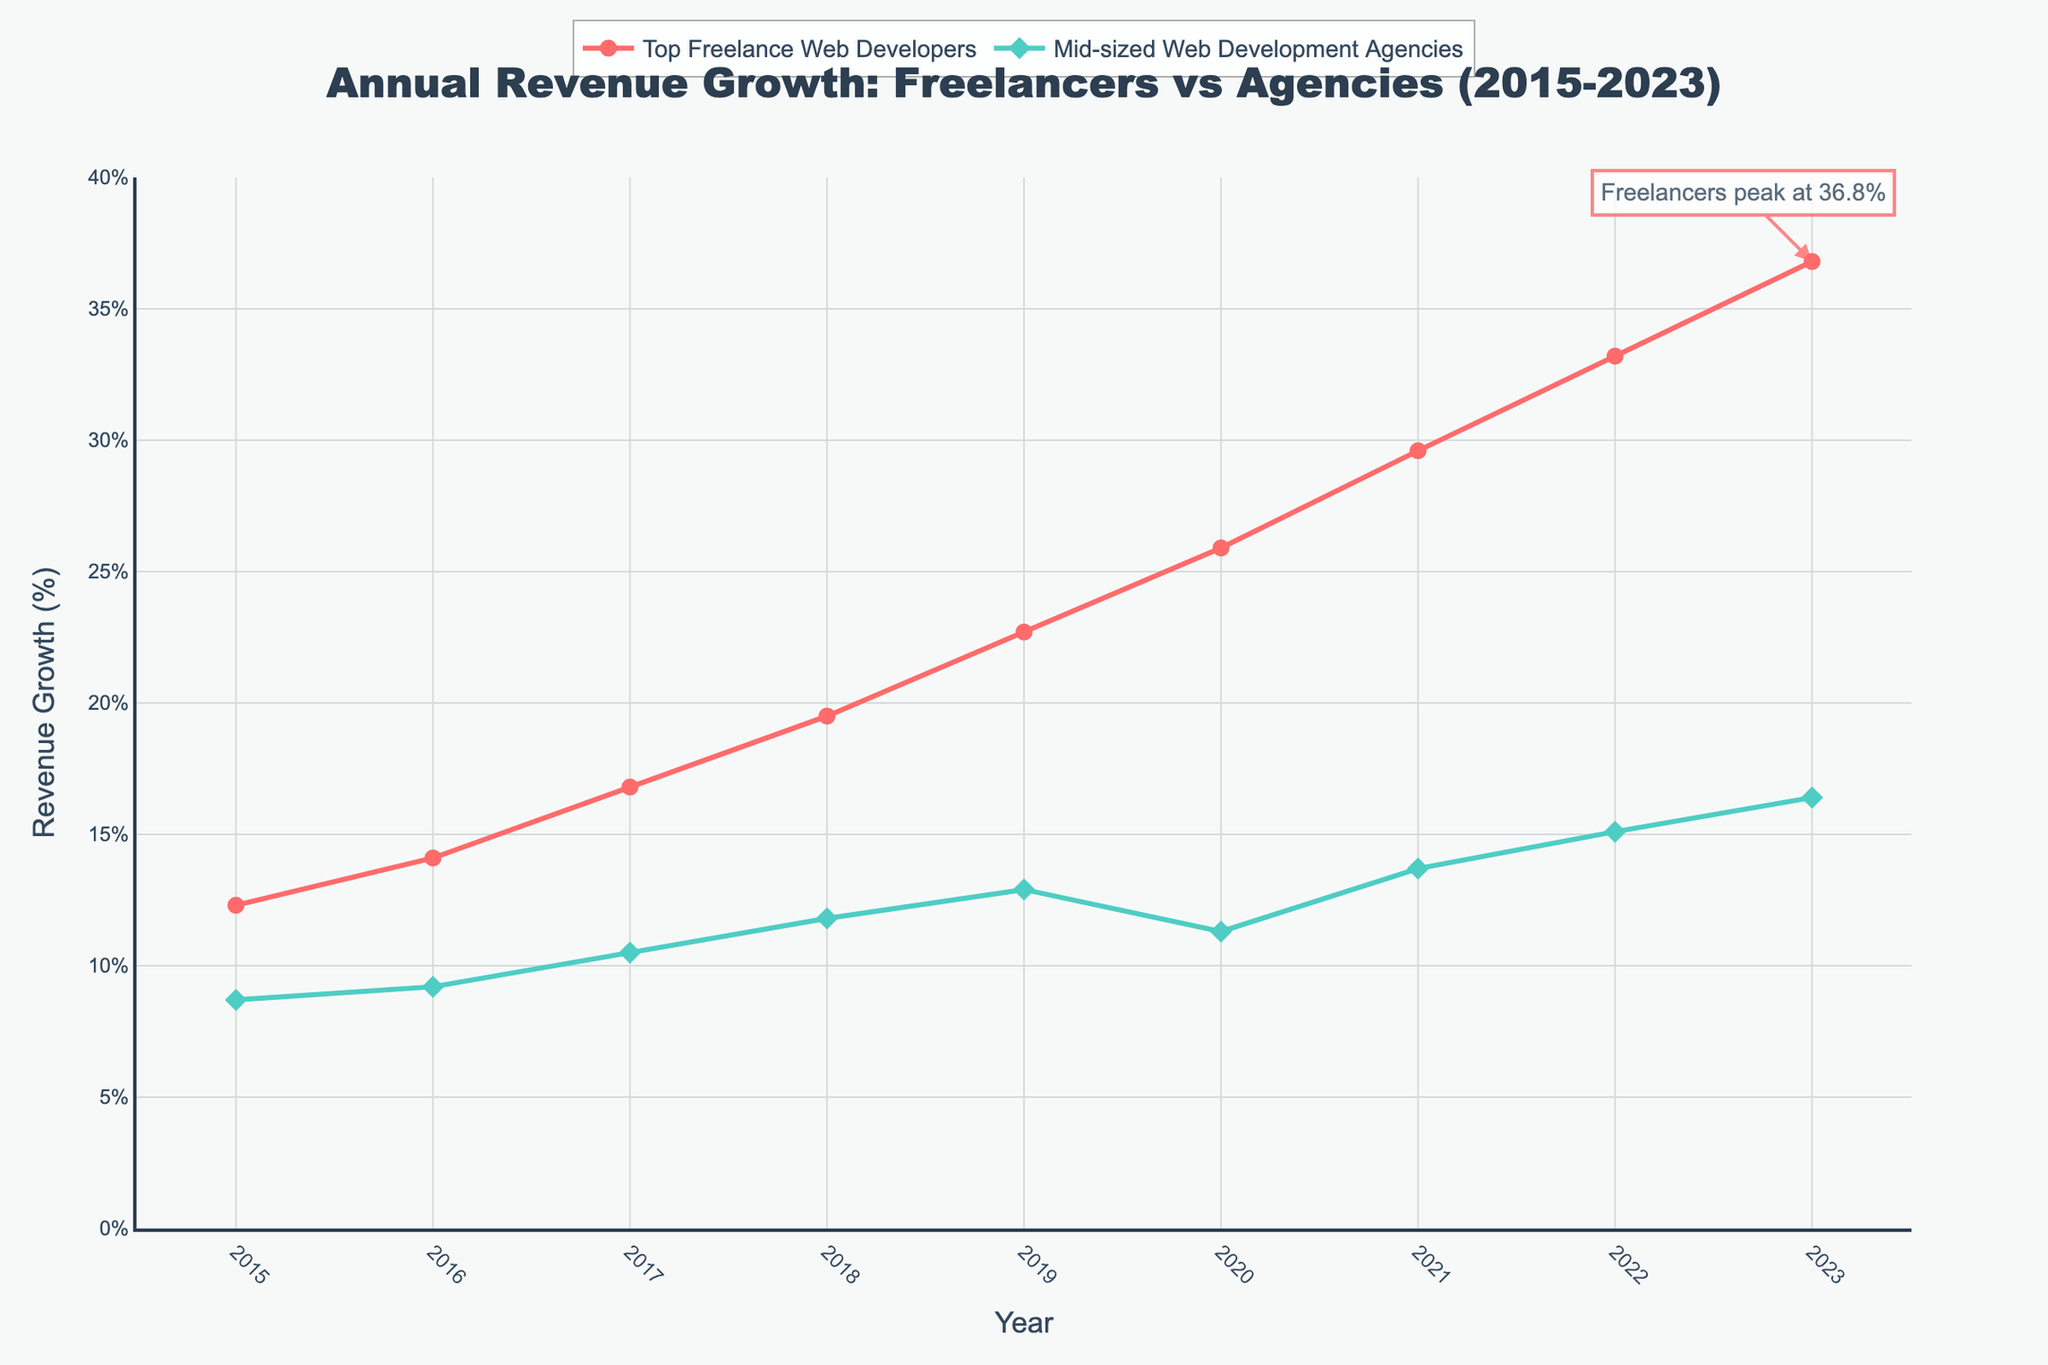What was the revenue growth for mid-sized web development agencies in 2019? Look for the value of revenue growth for mid-sized web development agencies in the year 2019, as displayed in the chart.
Answer: 12.9% How much did the revenue of top freelance web developers grow between 2015 and 2023? Subtract the revenue growth percentage of top freelance web developers in 2015 from that in 2023: 36.8% - 12.3%.
Answer: 24.5% Which group had a higher revenue growth in 2020, and by how much? Compare the revenue growth percentages for 2020: top freelance web developers had 25.9% and mid-sized web development agencies had 11.3%. Subtract the agencies' growth from the freelancers' growth: 25.9% - 11.3%.
Answer: Top freelance web developers, by 14.6% In which year did top freelance web developers surpass 20% revenue growth? Identify the year in which the revenue growth for top freelance web developers first exceeded 20% on the chart.
Answer: 2019 On average, by how much did the revenue growth of mid-sized web development agencies increase per year from 2015 to 2023? Calculate the net growth over the years for mid-sized agencies: 16.4% (2023) - 8.7% (2015) = 7.7%. Divide by the number of years: 7.7% / 8 years.
Answer: 0.9625% per year What was the difference in revenue growth between the two groups in 2018? Subtract the revenue growth of mid-sized web development agencies from that of top freelance web developers in 2018: 19.5% - 11.8%.
Answer: 7.7% How did the growth rate of mid-sized web development agencies change from 2019 to 2020? Subtract the revenue growth in 2020 from that in 2019 for mid-sized web development agencies: 12.9% - 11.3%.
Answer: Decreased by 1.6% Which group showed a consistent year-over-year growth, and which year saw the steepest increase for this group? Identify the group with year-over-year growth. For the steepest increase, find the year with the sharpest rise in revenue growth. Top freelance web developers increased every year. The steepest increase was from 2018 (19.5%) to 2019 (22.7%), an increase of 3.2%.
Answer: Top freelance web developers, 2019 By what percentage did the revenue growth of mid-sized web development agencies differ from that of top freelance web developers in 2021? Subtract the revenue growth of mid-sized web development agencies from that of top freelance web developers in 2021: 29.6% - 13.7%.
Answer: 15.9% Which group had the highest peak revenue growth, and what was that value? Look for the maximum revenue growth value on the chart for both groups. The highest growth is 36.8% for top freelance web developers.
Answer: Top freelance web developers, 36.8% 